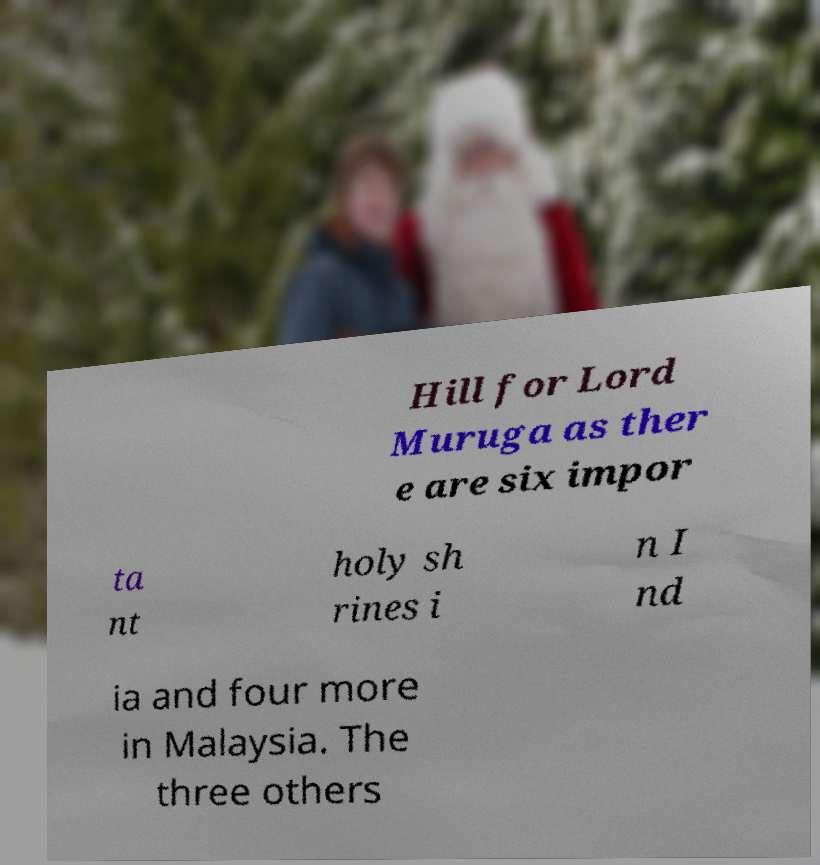For documentation purposes, I need the text within this image transcribed. Could you provide that? Hill for Lord Muruga as ther e are six impor ta nt holy sh rines i n I nd ia and four more in Malaysia. The three others 